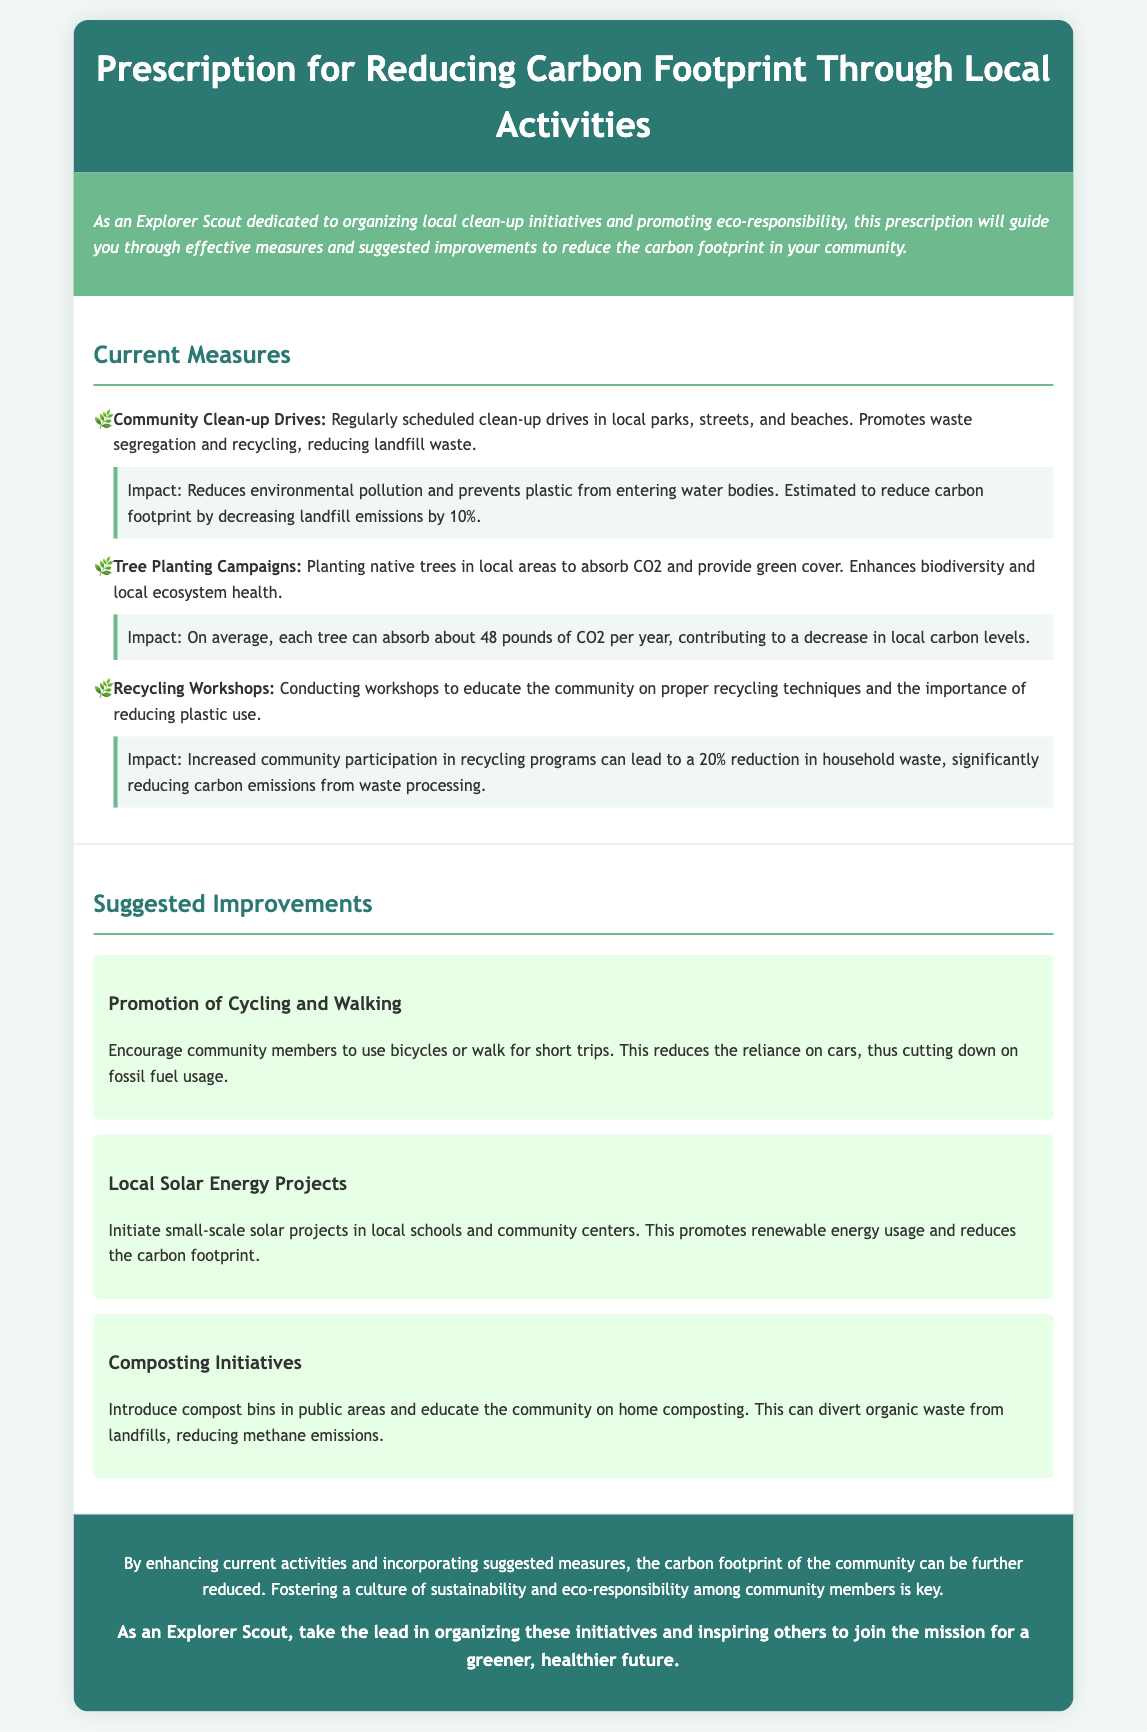What are the current measures listed? The current measures include community clean-up drives, tree planting campaigns, and recycling workshops.
Answer: Community clean-up drives, tree planting campaigns, recycling workshops What is the estimated reduction in carbon footprint from clean-up drives? The document states that clean-up drives can reduce landfill emissions by 10%.
Answer: 10% How much CO2 can each tree absorb per year? Each tree can absorb about 48 pounds of CO2 each year.
Answer: 48 pounds What improvement suggests promoting walking? The suggested improvement that encourages walking is titled "Promotion of Cycling and Walking."
Answer: Promotion of Cycling and Walking What impact does recycling have on household waste? Increased community participation in recycling programs can lead to a 20% reduction in household waste.
Answer: 20% How many suggested improvements are mentioned? The document presents three suggested improvements.
Answer: Three What is the focus of the conclusion in the document? The conclusion emphasizes enhancing activities and fostering a culture of sustainability among community members.
Answer: Enhancing activities and fostering sustainability What does the call-to-action encourage Explorer Scouts to do? The call-to-action encourages Explorer Scouts to organize initiatives and inspire others.
Answer: Organize initiatives and inspire others 